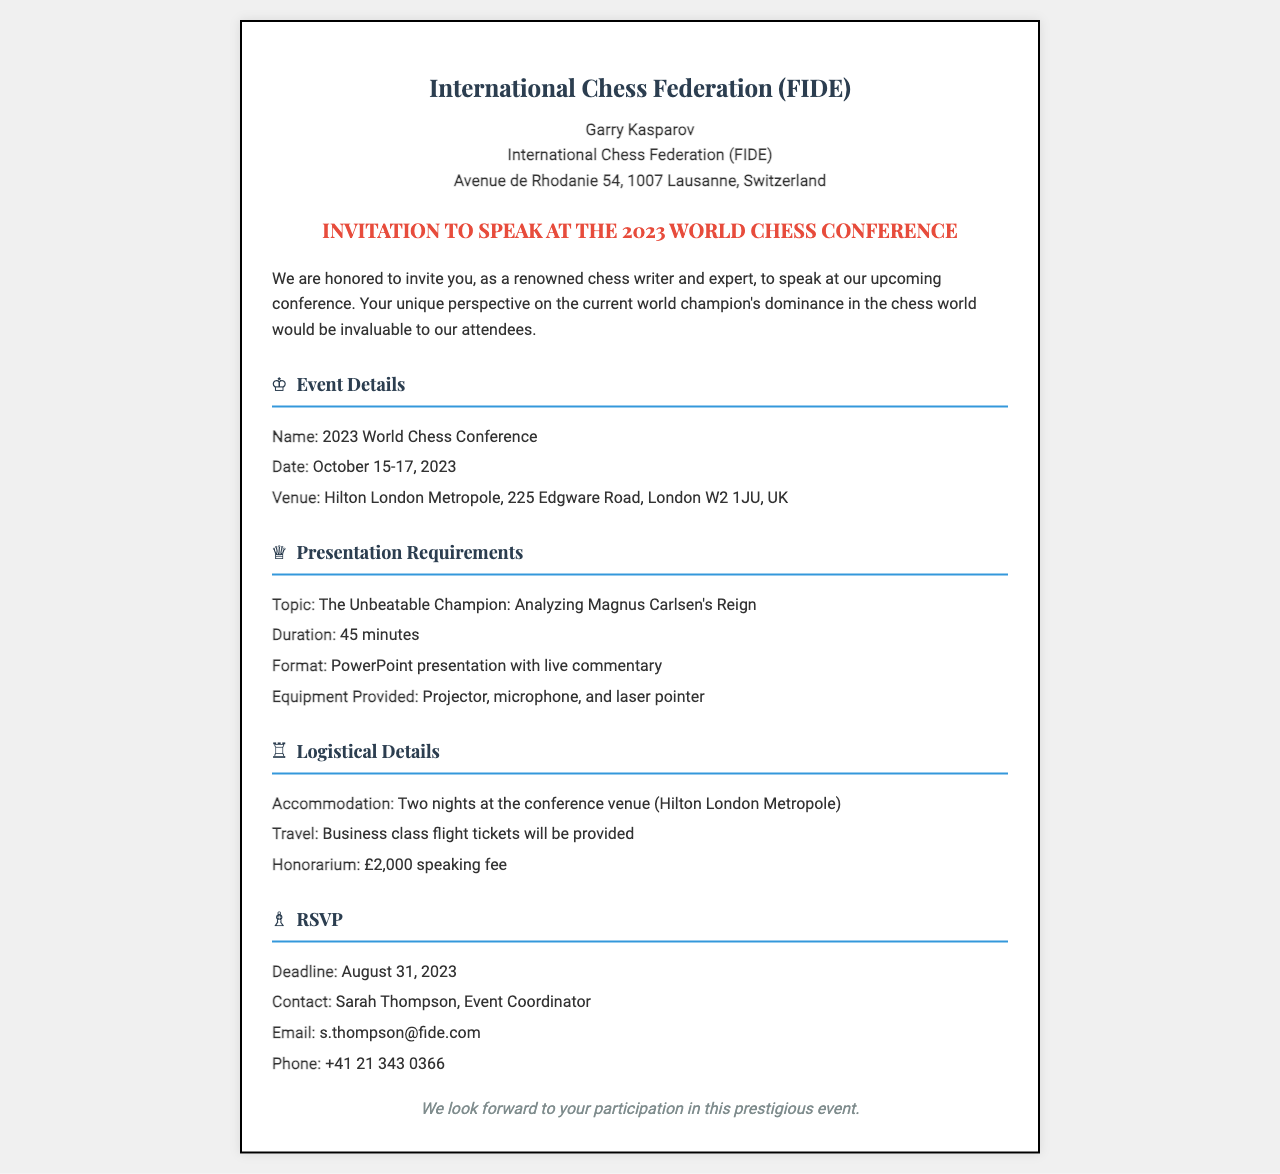What is the name of the conference? The name of the conference is provided in the event details section of the document.
Answer: 2023 World Chess Conference What are the conference dates? The conference dates are mentioned clearly in the event details section.
Answer: October 15-17, 2023 Where is the conference venue located? The venue address is given in the event details section of the document.
Answer: Hilton London Metropole, 225 Edgware Road, London W2 1JU, UK What is the topic of the presentation? The topic is specified in the presentation requirements section.
Answer: The Unbeatable Champion: Analyzing Magnus Carlsen's Reign How long is the presentation duration? The duration is listed in the presentation requirements section of the document.
Answer: 45 minutes What type of equipment will be provided for the presentation? The equipment provided is described in the presentation requirements section of the document.
Answer: Projector, microphone, and laser pointer Who should be contacted for RSVP? The contact person for RSVP is mentioned in the RSVP section of the document.
Answer: Sarah Thompson What is the honorarium amount? The honorarium is specified in the logistical details section of the document.
Answer: £2,000 When is the RSVP deadline? The deadline for RSVP is clearly stated in the RSVP section of the document.
Answer: August 31, 2023 